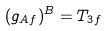<formula> <loc_0><loc_0><loc_500><loc_500>( g _ { A f } ) ^ { B } = T _ { 3 f }</formula> 